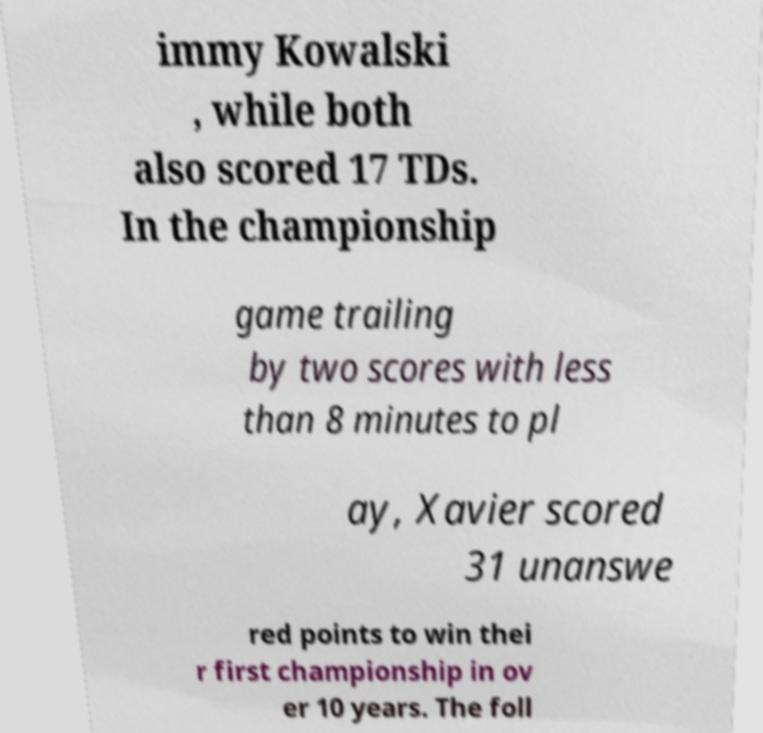Could you assist in decoding the text presented in this image and type it out clearly? immy Kowalski , while both also scored 17 TDs. In the championship game trailing by two scores with less than 8 minutes to pl ay, Xavier scored 31 unanswe red points to win thei r first championship in ov er 10 years. The foll 